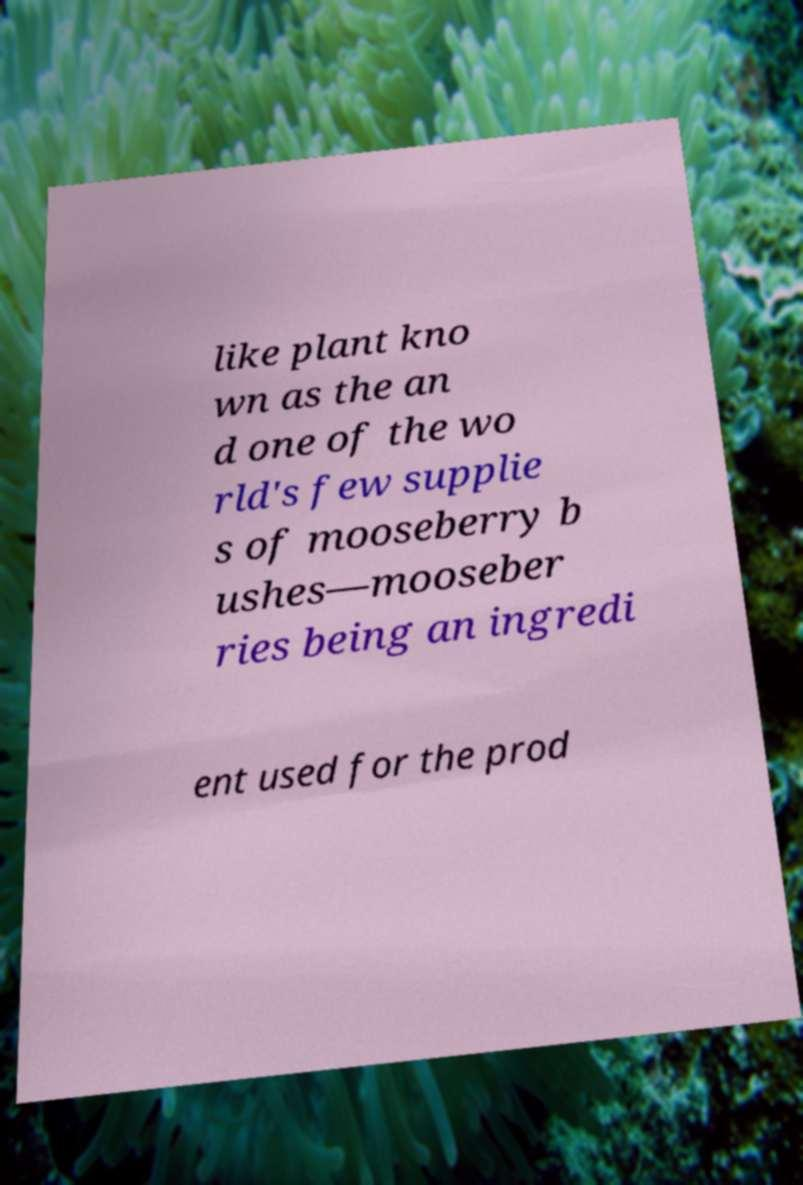What messages or text are displayed in this image? I need them in a readable, typed format. like plant kno wn as the an d one of the wo rld's few supplie s of mooseberry b ushes—mooseber ries being an ingredi ent used for the prod 